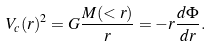<formula> <loc_0><loc_0><loc_500><loc_500>V _ { c } ( r ) ^ { 2 } = G \frac { M ( < r ) } { r } = - r \frac { d \Phi } { d r } .</formula> 